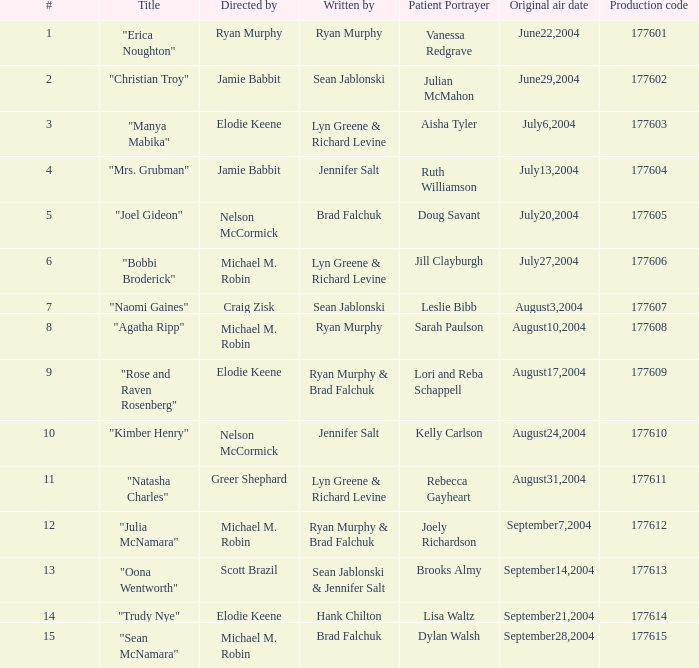How many episodes are labeled 4 in the season? 1.0. 